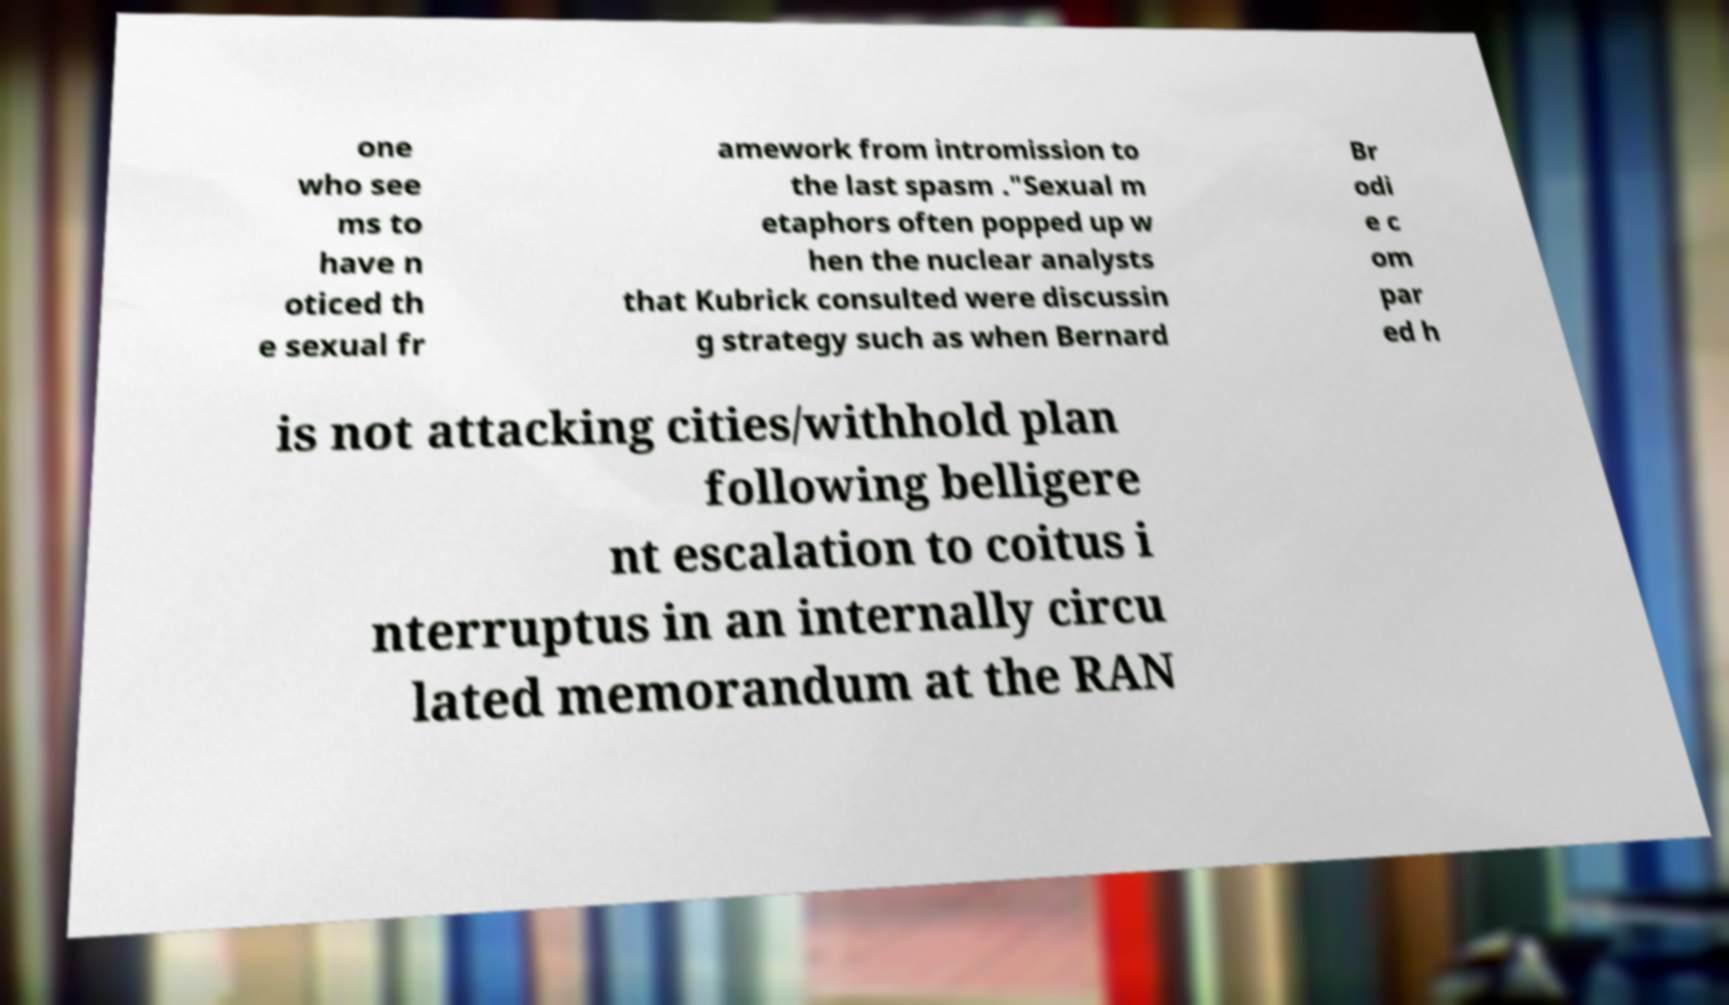Can you accurately transcribe the text from the provided image for me? one who see ms to have n oticed th e sexual fr amework from intromission to the last spasm ."Sexual m etaphors often popped up w hen the nuclear analysts that Kubrick consulted were discussin g strategy such as when Bernard Br odi e c om par ed h is not attacking cities/withhold plan following belligere nt escalation to coitus i nterruptus in an internally circu lated memorandum at the RAN 